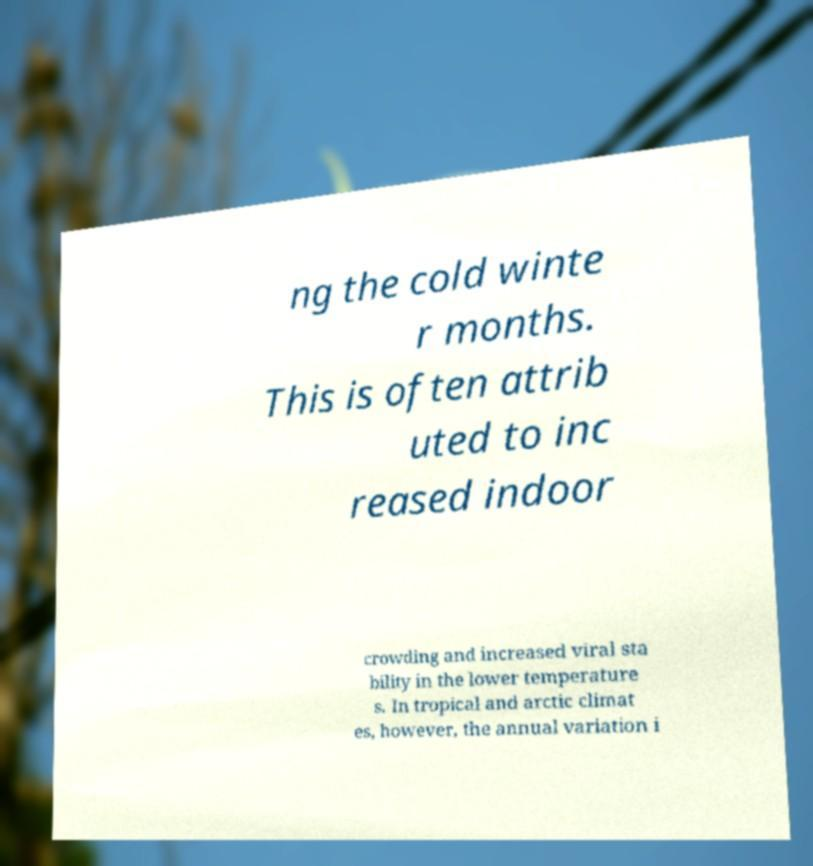Please identify and transcribe the text found in this image. ng the cold winte r months. This is often attrib uted to inc reased indoor crowding and increased viral sta bility in the lower temperature s. In tropical and arctic climat es, however, the annual variation i 